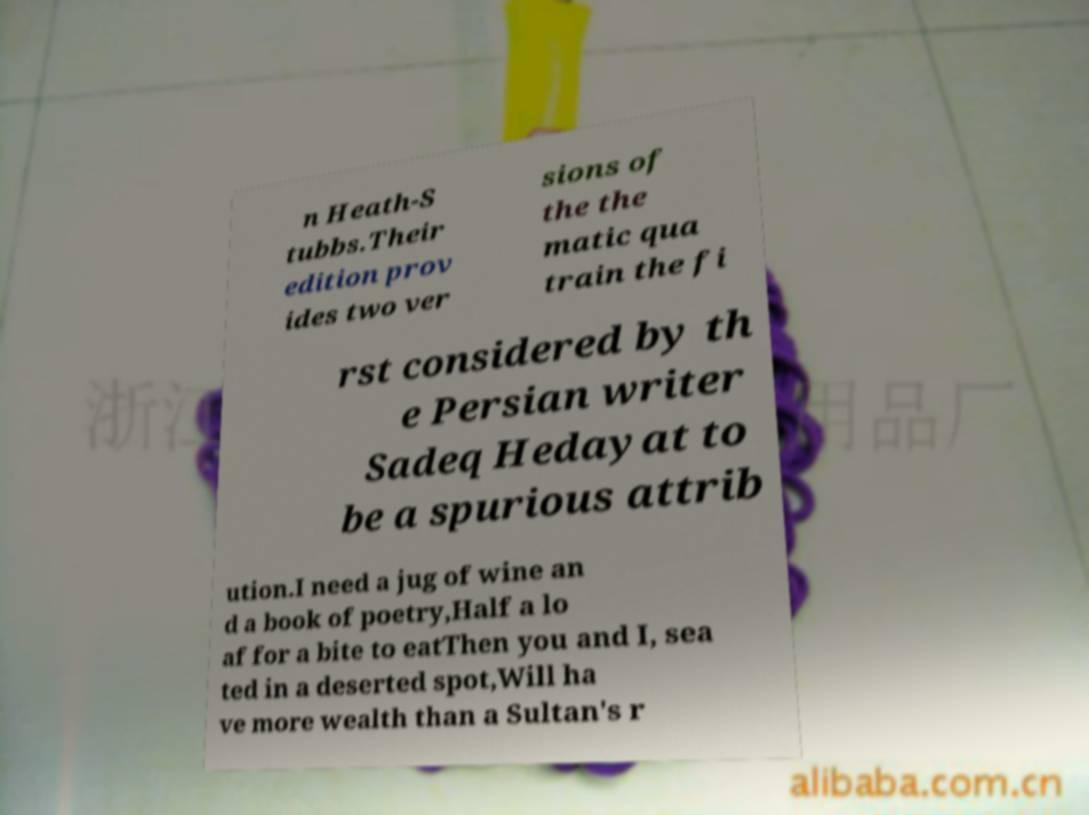Please read and relay the text visible in this image. What does it say? n Heath-S tubbs.Their edition prov ides two ver sions of the the matic qua train the fi rst considered by th e Persian writer Sadeq Hedayat to be a spurious attrib ution.I need a jug of wine an d a book of poetry,Half a lo af for a bite to eatThen you and I, sea ted in a deserted spot,Will ha ve more wealth than a Sultan's r 